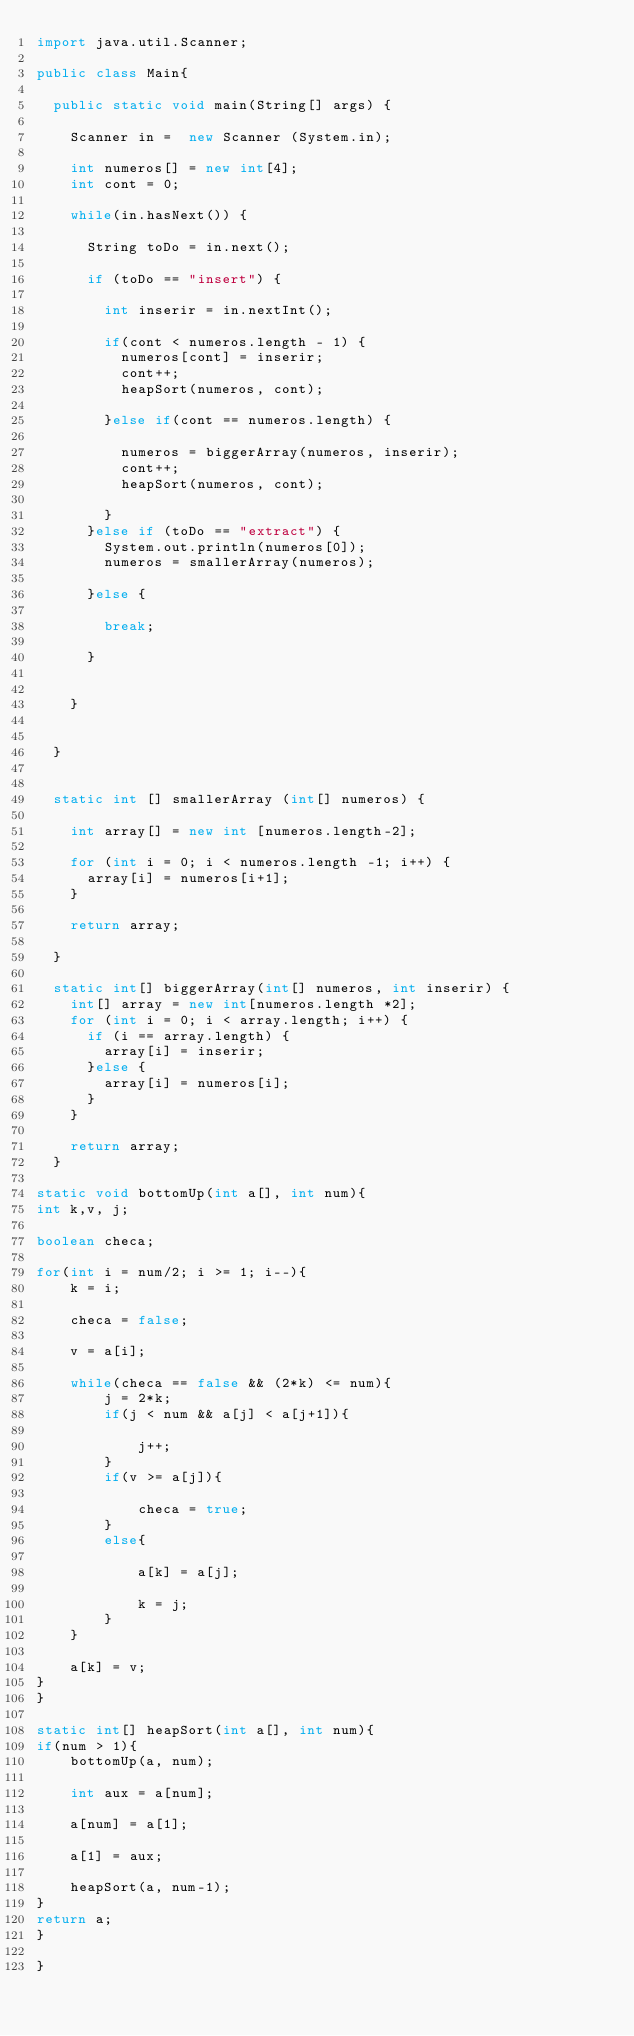<code> <loc_0><loc_0><loc_500><loc_500><_Java_>import java.util.Scanner;

public class Main{

	public static void main(String[] args) {
		
		Scanner in =  new Scanner (System.in);
		
		int numeros[] = new int[4];
		int cont = 0;
		
		while(in.hasNext()) {
			
			String toDo = in.next();
			
			if (toDo == "insert") {
				
				int inserir = in.nextInt();
				
				if(cont < numeros.length - 1) {
					numeros[cont] = inserir;
					cont++;
					heapSort(numeros, cont);
					
				}else if(cont == numeros.length) {
				
					numeros = biggerArray(numeros, inserir);
					cont++;
					heapSort(numeros, cont);
					
				}
			}else if (toDo == "extract") {
				System.out.println(numeros[0]);
				numeros = smallerArray(numeros);
				
			}else {
				
				break;
				
			}
		
			
		}
		

	}


	static int [] smallerArray (int[] numeros) {
		
		int array[] = new int [numeros.length-2];
		
		for (int i = 0; i < numeros.length -1; i++) {
			array[i] = numeros[i+1];
		}
		
		return array;
		
	}
	
	static int[] biggerArray(int[] numeros, int inserir) {
		int[] array = new int[numeros.length *2];
		for (int i = 0; i < array.length; i++) {
			if (i == array.length) {
				array[i] = inserir;
			}else {
				array[i] = numeros[i];
			}
		}

		return array;
	}

static void bottomUp(int a[], int num){
int k,v, j;

boolean checa;

for(int i = num/2; i >= 1; i--){
    k = i;

    checa = false;

    v = a[i];

    while(checa == false && (2*k) <= num){
        j = 2*k;
        if(j < num && a[j] < a[j+1]){

            j++;
        }
        if(v >= a[j]){

            checa = true;
        }
        else{

            a[k] = a[j];

            k = j;
        }
    }

    a[k] = v;
}
}

static int[] heapSort(int a[], int num){
if(num > 1){
    bottomUp(a, num);

    int aux = a[num];

    a[num] = a[1];

    a[1] = aux;

    heapSort(a, num-1);
}
return a;
}

}
</code> 